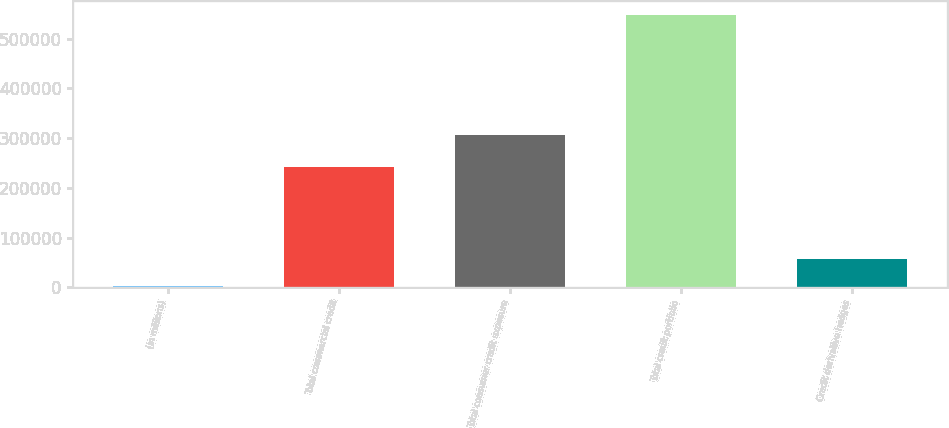<chart> <loc_0><loc_0><loc_500><loc_500><bar_chart><fcel>(in millions)<fcel>Total commercial credit<fcel>Total consumer credit exposure<fcel>Total credit portfolio<fcel>Credit derivative hedges<nl><fcel>2002<fcel>241340<fcel>306676<fcel>548016<fcel>56603.4<nl></chart> 